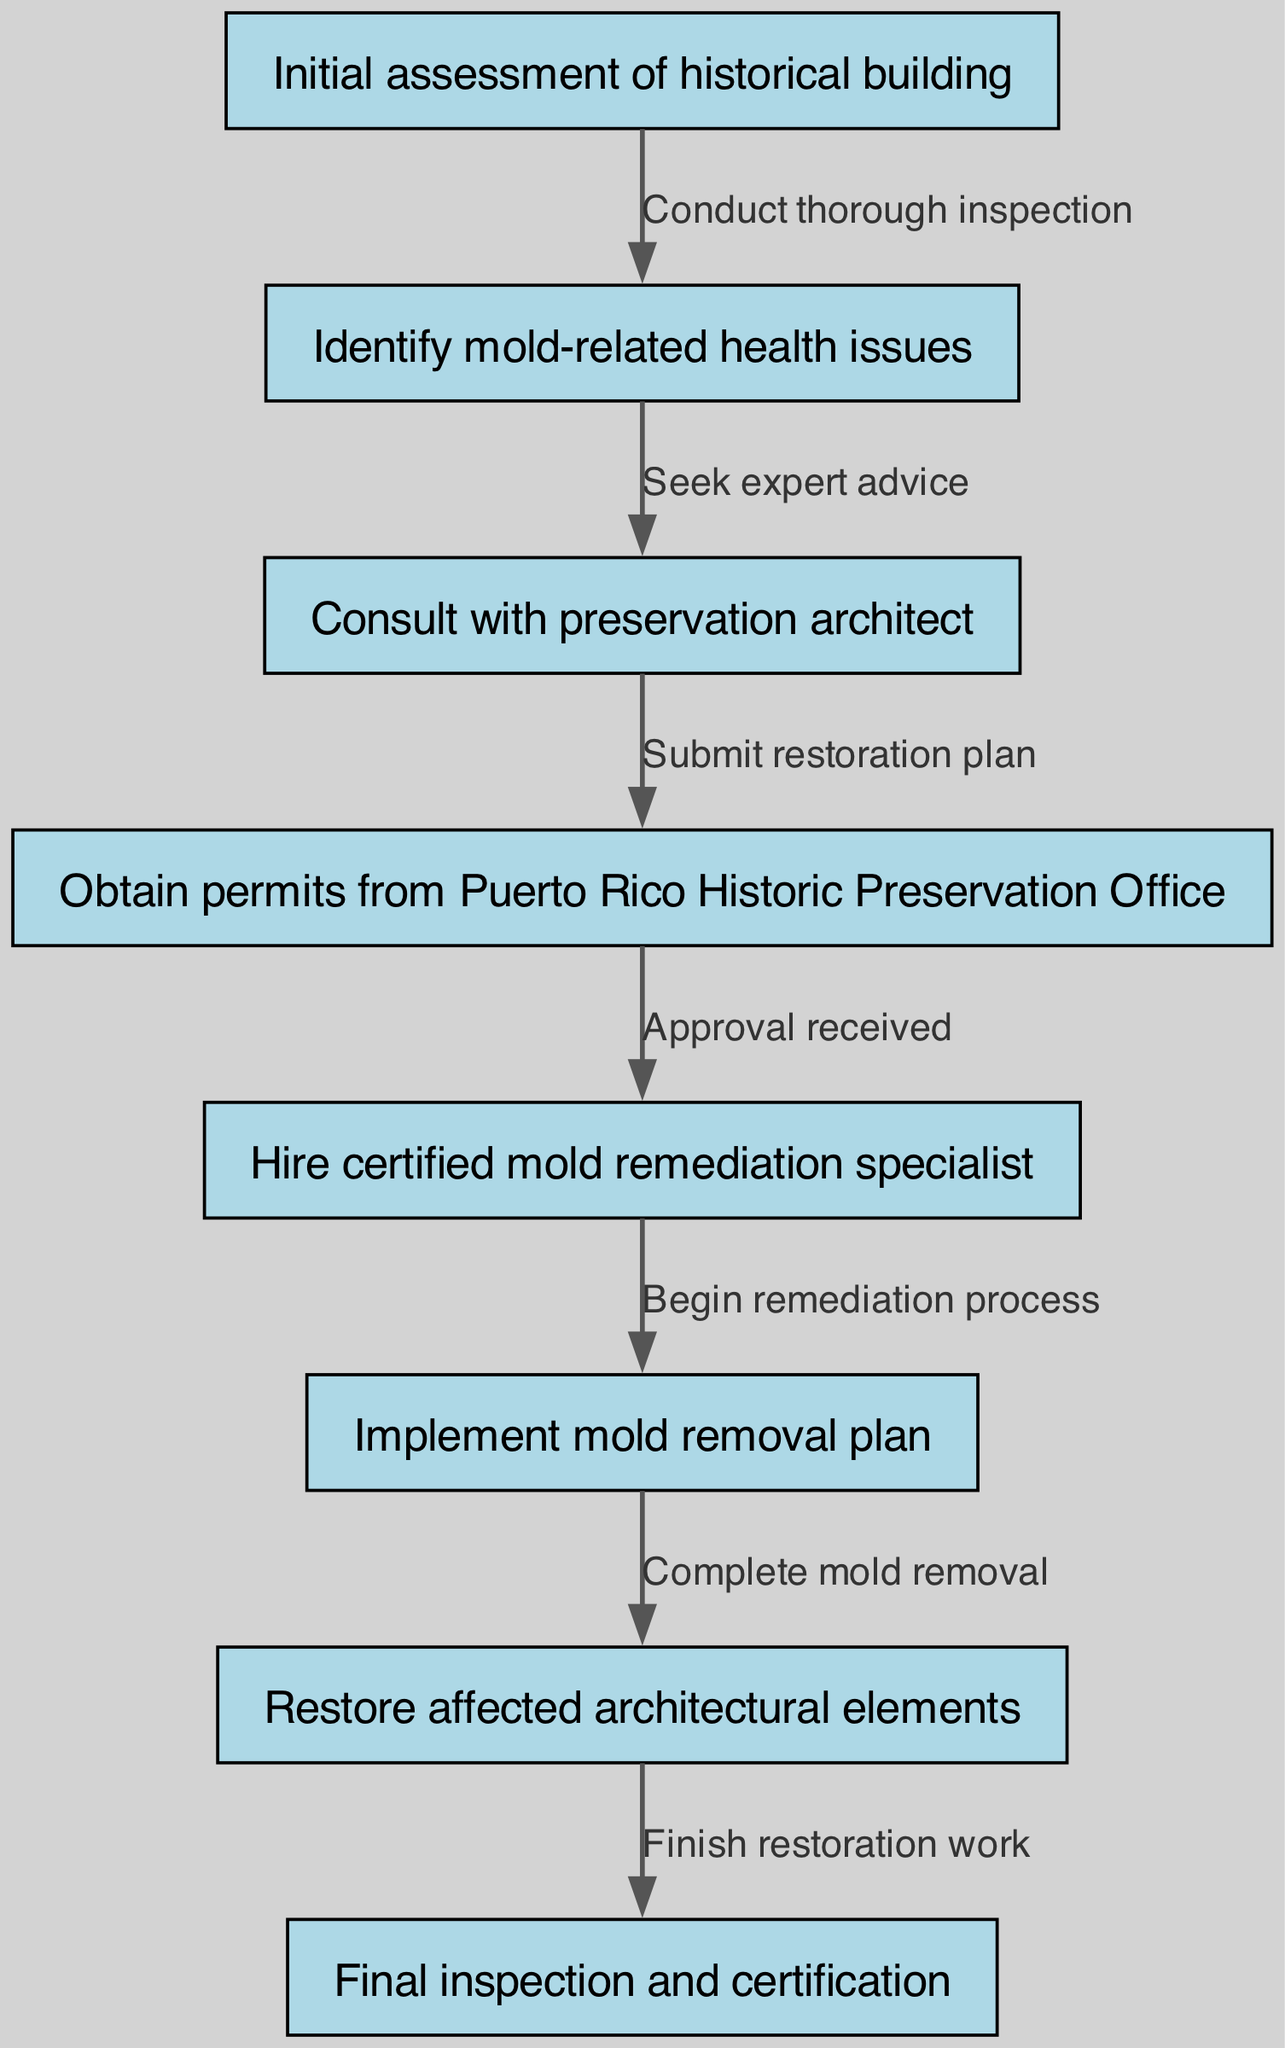What is the first step in the clinical pathway? The diagram indicates that the first step in the clinical pathway is "Initial assessment of historical building." This is the node labeled as the starting point.
Answer: Initial assessment of historical building How many nodes are in the diagram? By counting the individual nodes listed in the data, we find there are a total of 8 nodes representing different steps in the pathway.
Answer: 8 What is the last step in the clinical pathway? The final step shown in the diagram is "Final inspection and certification," which is the last node in the sequence.
Answer: Final inspection and certification Which step comes after obtaining permits? Following the step "Obtain permits from Puerto Rico Historic Preservation Office," the next step indicated is "Hire certified mold remediation specialist." This is clearly marked as the subsequent action.
Answer: Hire certified mold remediation specialist What is the relationship between the initial assessment and identifying mold-related health issues? The relationship is represented by an edge labeled "Conduct thorough inspection," which connects these two nodes, illustrating that the initial assessment leads to identifying any mold-related issues.
Answer: Conduct thorough inspection Which step requires expert advice? According to the diagram, the step "Identify mold-related health issues" is where expert advice is sought, as indicated by the connection to the next step.
Answer: Identify mold-related health issues How many steps involve mold remediation? The steps that directly involve mold remediation include "Hire certified mold remediation specialist," "Implement mold removal plan," and "Complete mold removal," which totals to 3 steps.
Answer: 3 What must be received before proceeding to hire a specialist? The diagram indicates that "Approval received" from the Puerto Rico Historic Preservation Office must be obtained before moving to the hiring of the remediation specialist.
Answer: Approval received What happens after mold removal is complete? The next step after "Complete mold removal" is "Restore affected architectural elements," indicating the continuation of the restoration process after remediation.
Answer: Restore affected architectural elements 